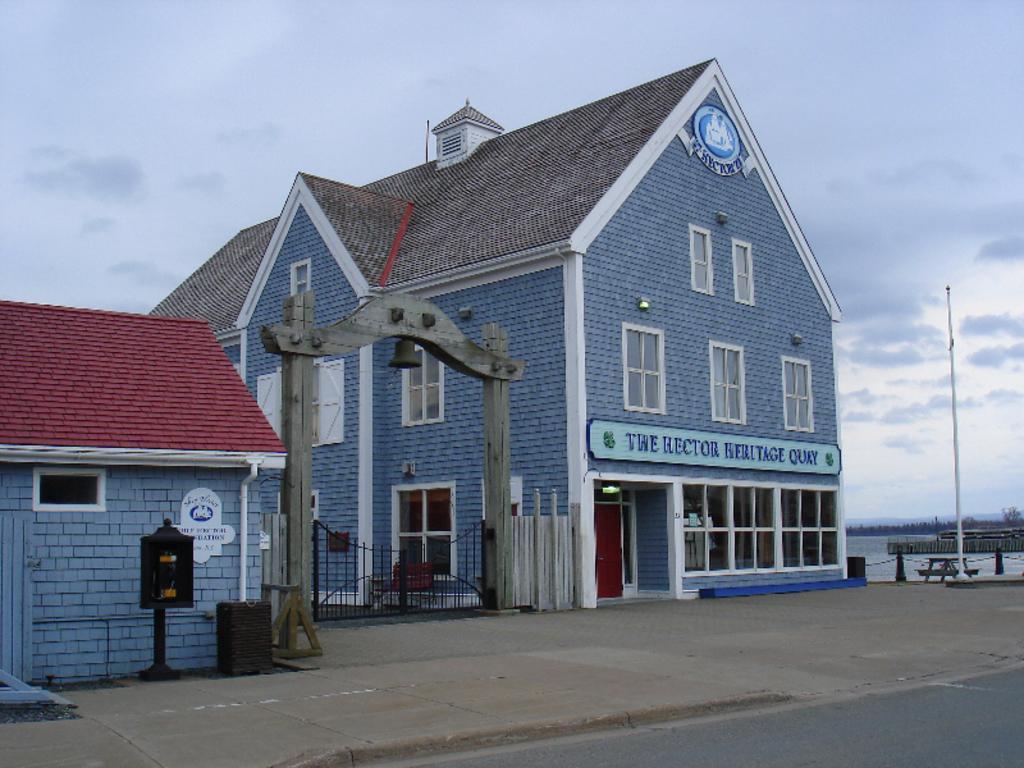Could you give a brief overview of what you see in this image? In this image we can see some buildings with windows and roof. We can also see a board, a bell on an arch, a gate, some poles, a water body, a group of trees and the sky. 